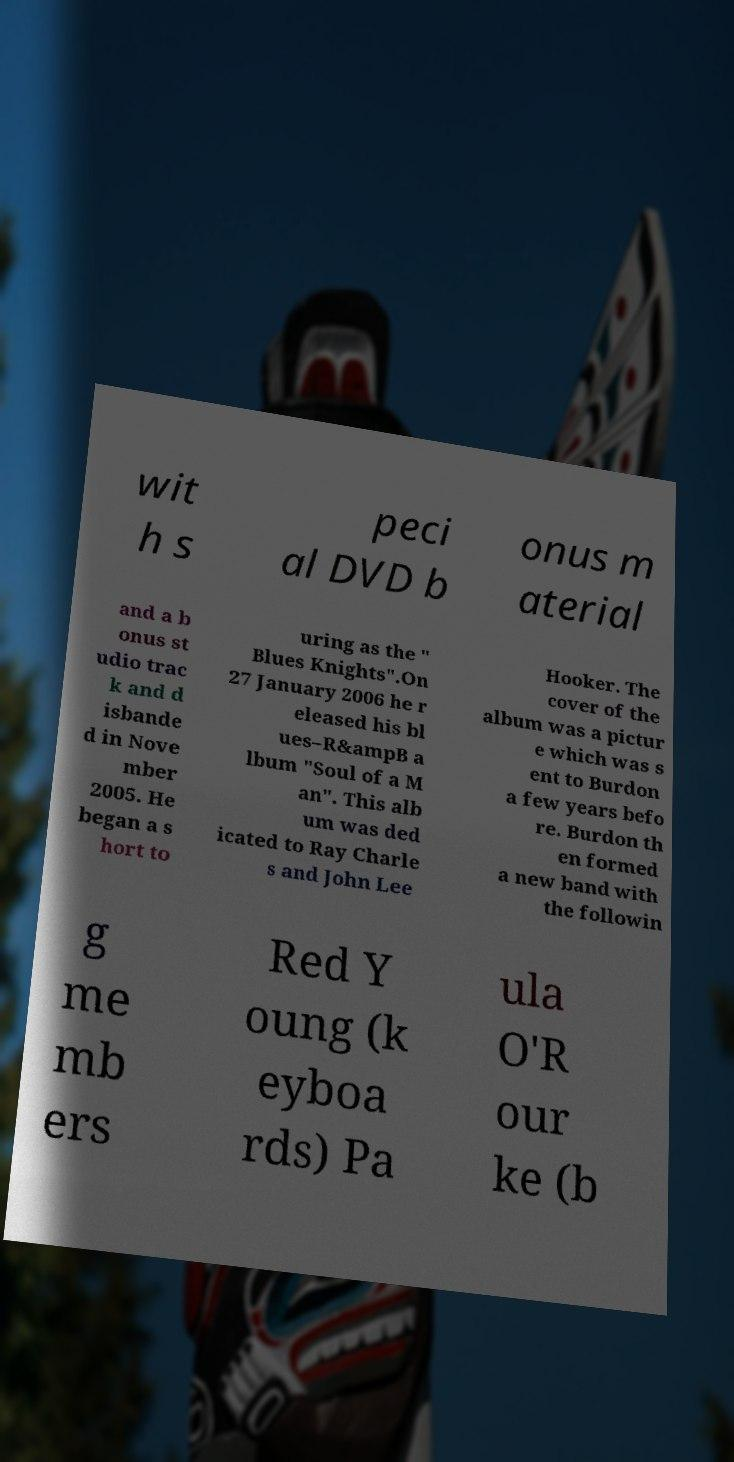For documentation purposes, I need the text within this image transcribed. Could you provide that? wit h s peci al DVD b onus m aterial and a b onus st udio trac k and d isbande d in Nove mber 2005. He began a s hort to uring as the " Blues Knights".On 27 January 2006 he r eleased his bl ues–R&ampB a lbum "Soul of a M an". This alb um was ded icated to Ray Charle s and John Lee Hooker. The cover of the album was a pictur e which was s ent to Burdon a few years befo re. Burdon th en formed a new band with the followin g me mb ers Red Y oung (k eyboa rds) Pa ula O'R our ke (b 